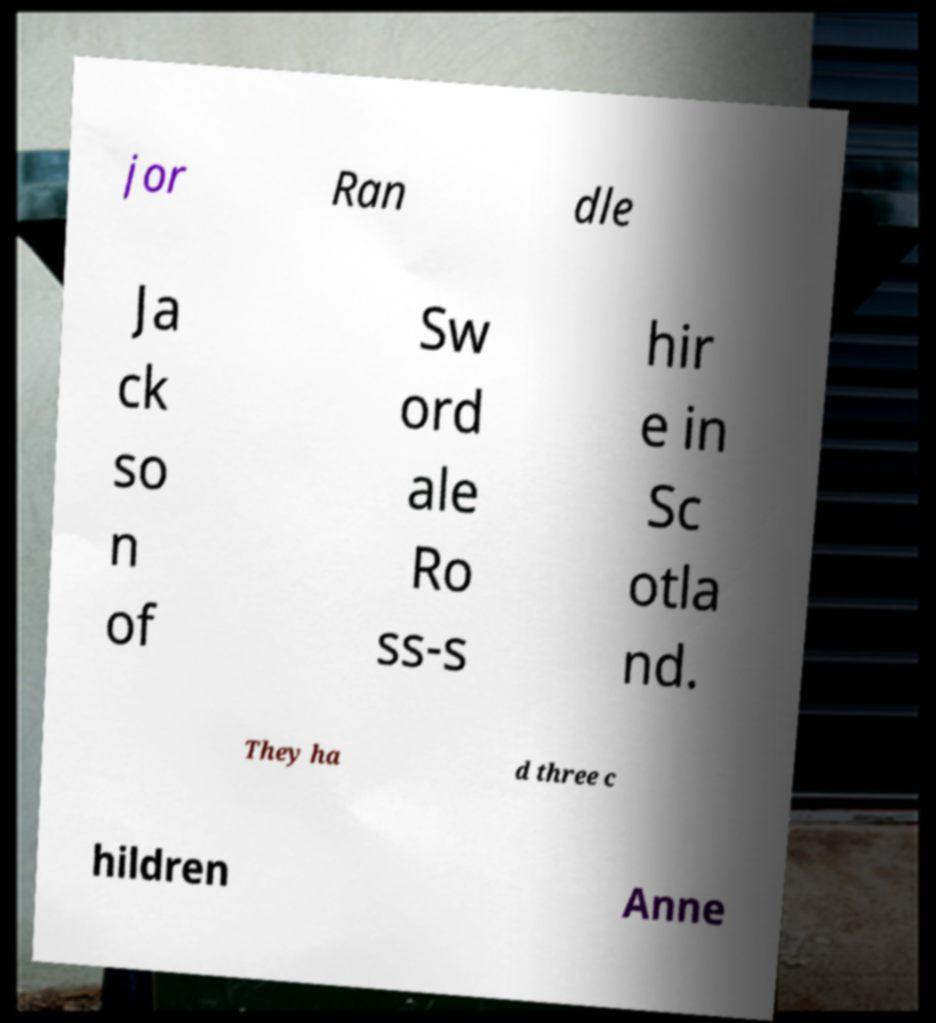Could you extract and type out the text from this image? jor Ran dle Ja ck so n of Sw ord ale Ro ss-s hir e in Sc otla nd. They ha d three c hildren Anne 